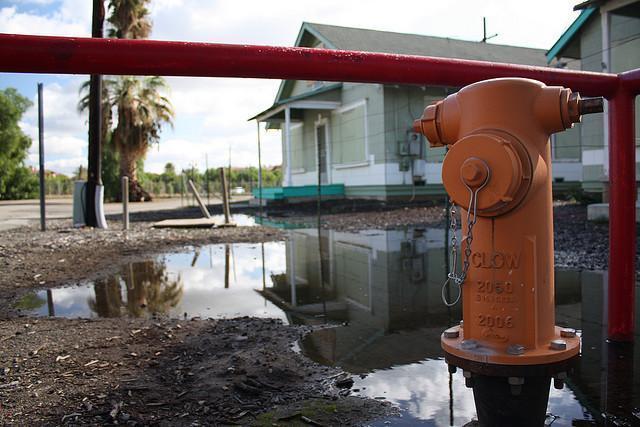How many toilets are there?
Give a very brief answer. 0. 